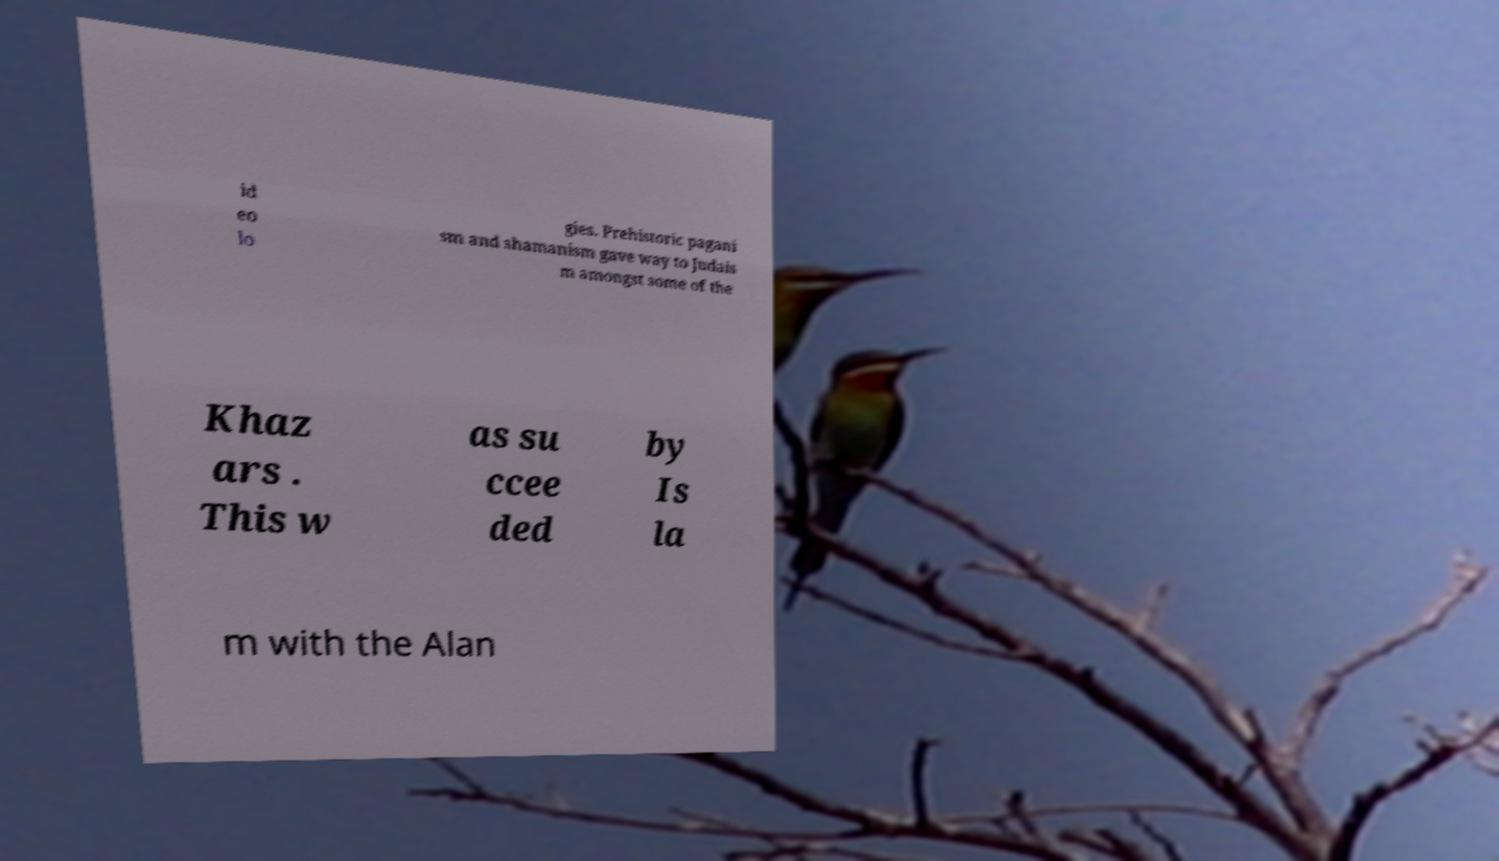For documentation purposes, I need the text within this image transcribed. Could you provide that? id eo lo gies. Prehistoric pagani sm and shamanism gave way to Judais m amongst some of the Khaz ars . This w as su ccee ded by Is la m with the Alan 